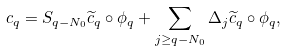Convert formula to latex. <formula><loc_0><loc_0><loc_500><loc_500>c _ { q } = S _ { q - N _ { 0 } } \widetilde { c } _ { q } \circ \phi _ { q } + \sum _ { j \geq q - N _ { 0 } } \Delta _ { j } \widetilde { c } _ { q } \circ \phi _ { q } ,</formula> 